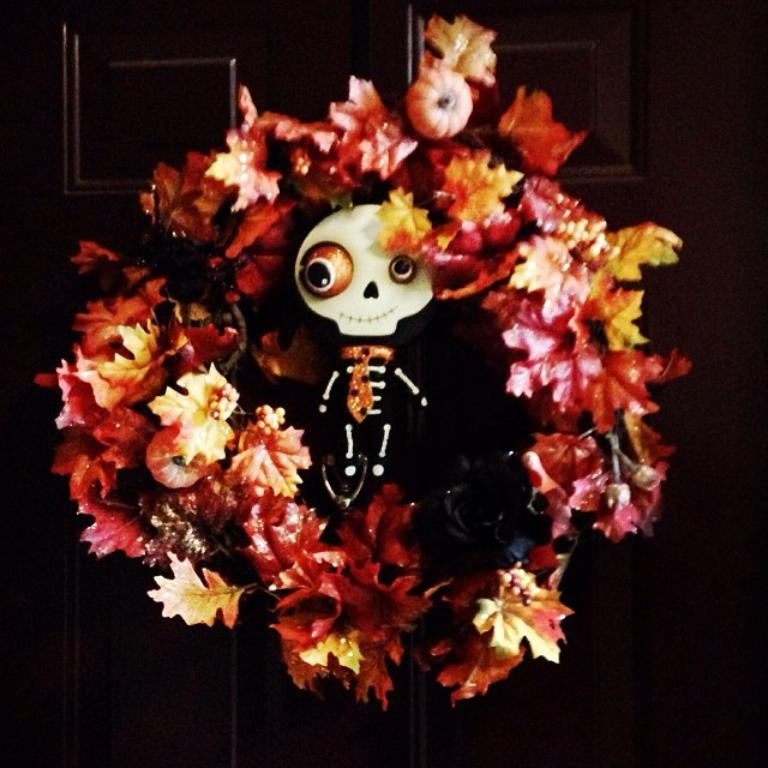What type of plants are present in the image? There are flowers in the image. What other object can be seen in the image? There is a skeleton with a skull in the image. What is in the background of the image? There is a wooden board in the background of the image. How many lizards are sitting on the flowers in the image? There are no lizards present in the image; it only features flowers, a skeleton with a skull, and a wooden board. 